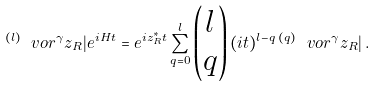<formula> <loc_0><loc_0><loc_500><loc_500>\, ^ { ( l ) } \ v o r ^ { \gamma } z _ { R } | e ^ { i H t } = e ^ { i z _ { R } ^ { * } t } \sum _ { q = 0 } ^ { l } \begin{pmatrix} l \\ q \end{pmatrix} ( i t ) ^ { l - q } \, ^ { ( q ) } \ v o r ^ { \gamma } z _ { R } | \, .</formula> 